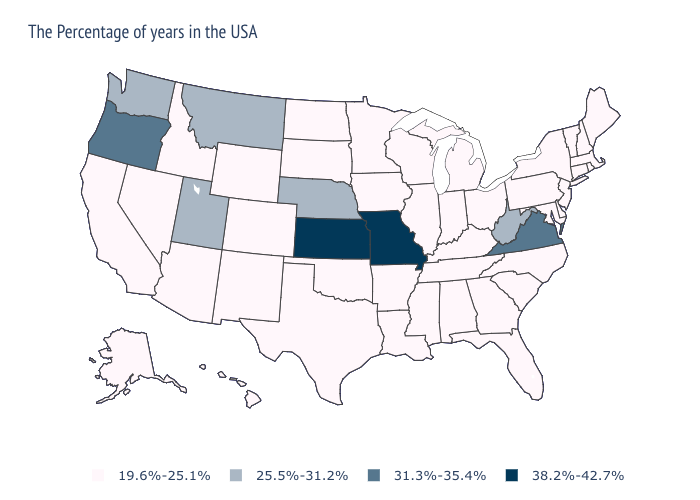Does the first symbol in the legend represent the smallest category?
Keep it brief. Yes. What is the lowest value in states that border South Carolina?
Be succinct. 19.6%-25.1%. Does Michigan have the lowest value in the USA?
Concise answer only. Yes. Name the states that have a value in the range 38.2%-42.7%?
Quick response, please. Missouri, Kansas. What is the value of California?
Short answer required. 19.6%-25.1%. Name the states that have a value in the range 25.5%-31.2%?
Answer briefly. West Virginia, Nebraska, Utah, Montana, Washington. What is the value of Washington?
Give a very brief answer. 25.5%-31.2%. What is the value of Arizona?
Keep it brief. 19.6%-25.1%. Name the states that have a value in the range 25.5%-31.2%?
Short answer required. West Virginia, Nebraska, Utah, Montana, Washington. Is the legend a continuous bar?
Short answer required. No. Does New Jersey have the same value as Montana?
Give a very brief answer. No. Which states have the lowest value in the South?
Give a very brief answer. Delaware, Maryland, North Carolina, South Carolina, Florida, Georgia, Kentucky, Alabama, Tennessee, Mississippi, Louisiana, Arkansas, Oklahoma, Texas. Name the states that have a value in the range 38.2%-42.7%?
Keep it brief. Missouri, Kansas. 